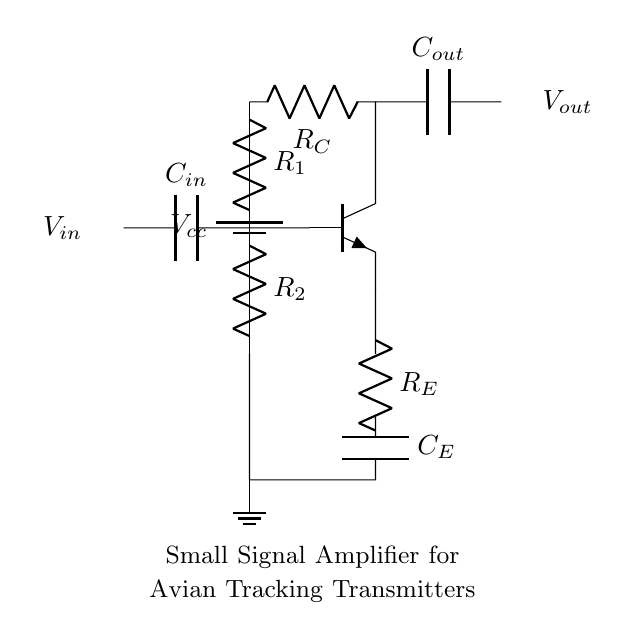What type of transistor is used in this amplifier circuit? The transistor used is an NPN type, indicated by the label npn in the circuit diagram.
Answer: NPN What are the component labels of the biasing resistors? The biasing resistors are labeled R1 and R2 in the circuit diagram, which are connected to the base of the transistor.
Answer: R1, R2 What is the purpose of the capacitor labeled C_E? The capacitor C_E is connected in the emitter leg, usually for AC coupling, which allows AC signals to pass while blocking DC.
Answer: AC coupling How is the input voltage labeled in the circuit? The input voltage is labeled V_in and is connected through a capacitor C_in to the base of the transistor.
Answer: V_in What does the output voltage connect to in this circuit? The output voltage V_out is connected through the capacitor C_out, which allows the amplified signal to pass while blocking DC levels.
Answer: C_out What value is typically used for the biasing resistors in small signal amplifiers? The value of biasing resistors like R1 and R2 can vary; common values range from thousands of ohms (1k to 100k).
Answer: 1k to 100k 